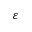Convert formula to latex. <formula><loc_0><loc_0><loc_500><loc_500>\varepsilon</formula> 